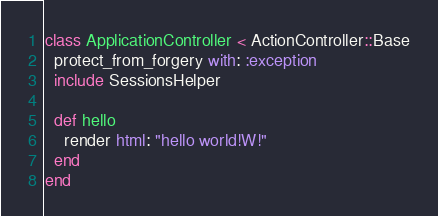Convert code to text. <code><loc_0><loc_0><loc_500><loc_500><_Ruby_>class ApplicationController < ActionController::Base
  protect_from_forgery with: :exception
  include SessionsHelper

  def hello
    render html: "hello world!W!"
  end
end
</code> 